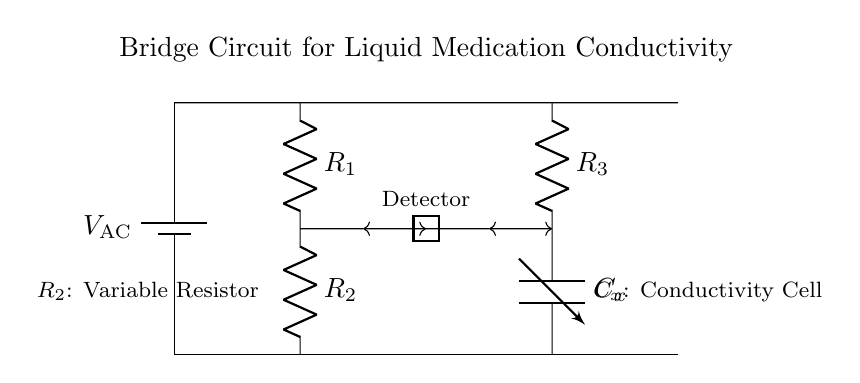What is the voltage source in this circuit? The voltage source is labeled as V_AC, which is positioned on the left side of the circuit diagram. This indicates the AC power supply that powers the bridge circuit.
Answer: V_AC How many resistors are in this bridge circuit? The circuit contains three resistors, which are labeled as R1, R2, and R3. These resistors are part of the bridge configuration used to measure conductivity.
Answer: 3 What is the function of C_x in the circuit? C_x, labeled as the conductivity cell, is a variable capacitor used for measuring the conductivity of liquid medications. Its specific function is to respond to the conductivity changes of the liquid by altering capacitance.
Answer: Conductivity Cell Which resistor is variable? R2 is identified as the variable resistor in the circuit, as indicated by the label. This allows for adjustment based on the required measurement conditions in the bridge circuit.
Answer: R2 What connections are made to the detector? The detector connects to two points in the circuit, one between R1 and R2, and another between R3 and C_x, allowing it to measure the output voltage of the bridge for conductivity comparison.
Answer: Between R1, R2 & R3, C_x What is the purpose of the bridge circuit? The main purpose of the bridge circuit is to measure the conductivity of liquid medications, which is achieved by comparing the resistance and capacitance in the given configuration.
Answer: Measure Conductivity What type of bridge circuit is depicted here? This is an AC bridge circuit, specifically designed to measure the conductivity of liquids using alternating current, differentiating it from DC circuits.
Answer: AC Bridge 